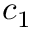<formula> <loc_0><loc_0><loc_500><loc_500>c _ { 1 }</formula> 